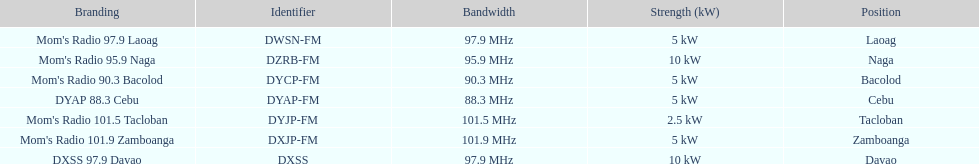How many stations broadcast with a power of 5kw? 4. 